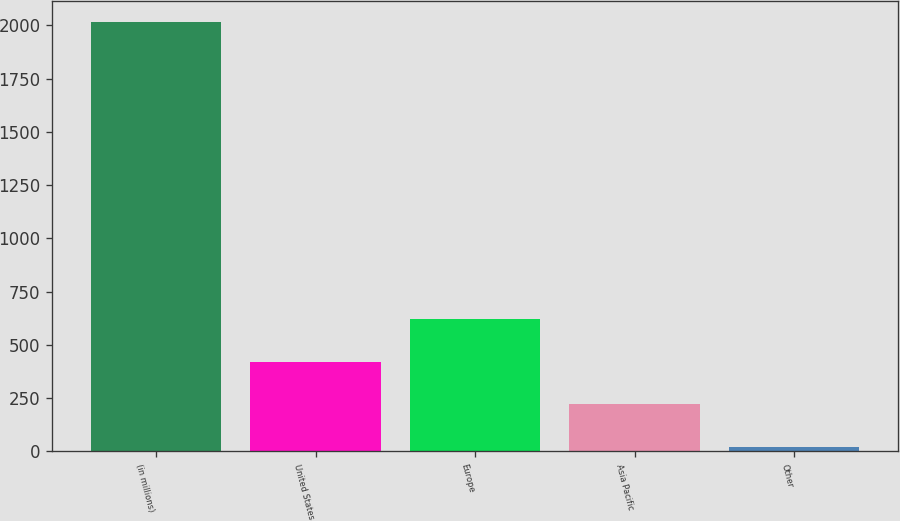Convert chart to OTSL. <chart><loc_0><loc_0><loc_500><loc_500><bar_chart><fcel>(in millions)<fcel>United States<fcel>Europe<fcel>Asia Pacific<fcel>Other<nl><fcel>2014<fcel>420.4<fcel>619.6<fcel>221.2<fcel>22<nl></chart> 